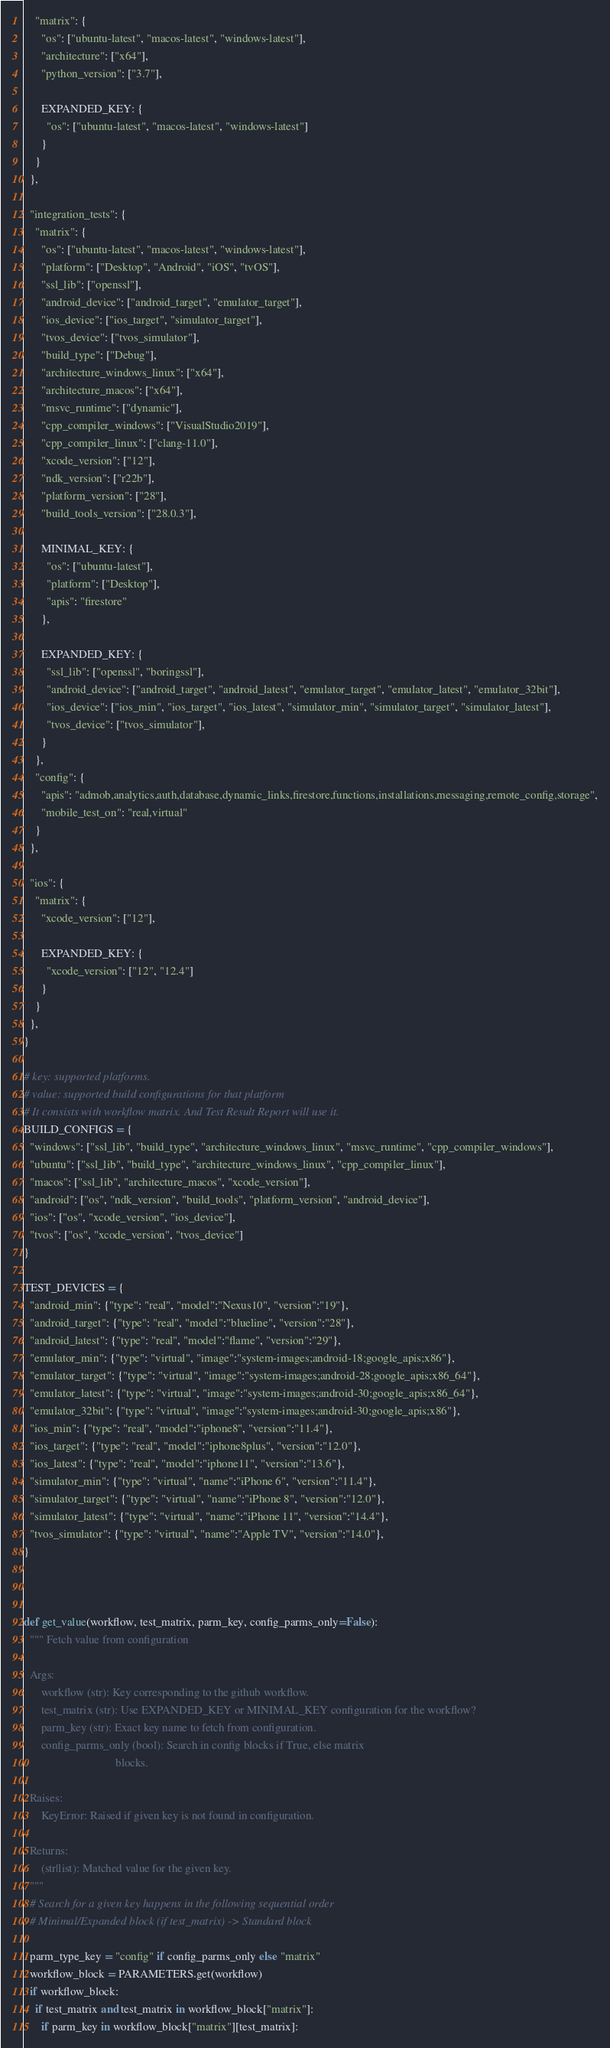Convert code to text. <code><loc_0><loc_0><loc_500><loc_500><_Python_>    "matrix": {
      "os": ["ubuntu-latest", "macos-latest", "windows-latest"],
      "architecture": ["x64"],
      "python_version": ["3.7"],

      EXPANDED_KEY: {
        "os": ["ubuntu-latest", "macos-latest", "windows-latest"]
      }
    }
  },

  "integration_tests": {
    "matrix": {
      "os": ["ubuntu-latest", "macos-latest", "windows-latest"],
      "platform": ["Desktop", "Android", "iOS", "tvOS"],
      "ssl_lib": ["openssl"],
      "android_device": ["android_target", "emulator_target"],
      "ios_device": ["ios_target", "simulator_target"],
      "tvos_device": ["tvos_simulator"],
      "build_type": ["Debug"],
      "architecture_windows_linux": ["x64"],
      "architecture_macos": ["x64"],
      "msvc_runtime": ["dynamic"],
      "cpp_compiler_windows": ["VisualStudio2019"],
      "cpp_compiler_linux": ["clang-11.0"],
      "xcode_version": ["12"],
      "ndk_version": ["r22b"],
      "platform_version": ["28"],
      "build_tools_version": ["28.0.3"],

      MINIMAL_KEY: {
        "os": ["ubuntu-latest"],
        "platform": ["Desktop"],
        "apis": "firestore"
      },

      EXPANDED_KEY: {
        "ssl_lib": ["openssl", "boringssl"],
        "android_device": ["android_target", "android_latest", "emulator_target", "emulator_latest", "emulator_32bit"],
        "ios_device": ["ios_min", "ios_target", "ios_latest", "simulator_min", "simulator_target", "simulator_latest"],
        "tvos_device": ["tvos_simulator"],
      }
    },
    "config": {
      "apis": "admob,analytics,auth,database,dynamic_links,firestore,functions,installations,messaging,remote_config,storage",
      "mobile_test_on": "real,virtual"
    }
  },

  "ios": {
    "matrix": {
      "xcode_version": ["12"],

      EXPANDED_KEY: {
        "xcode_version": ["12", "12.4"]
      }
    }
  },
}

# key: supported platforms.
# value: supported build configurations for that platform
# It consists with workflow matrix. And Test Result Report will use it.
BUILD_CONFIGS = {
  "windows": ["ssl_lib", "build_type", "architecture_windows_linux", "msvc_runtime", "cpp_compiler_windows"],
  "ubuntu": ["ssl_lib", "build_type", "architecture_windows_linux", "cpp_compiler_linux"],
  "macos": ["ssl_lib", "architecture_macos", "xcode_version"],
  "android": ["os", "ndk_version", "build_tools", "platform_version", "android_device"],
  "ios": ["os", "xcode_version", "ios_device"],
  "tvos": ["os", "xcode_version", "tvos_device"]
}

TEST_DEVICES = {
  "android_min": {"type": "real", "model":"Nexus10", "version":"19"},
  "android_target": {"type": "real", "model":"blueline", "version":"28"},
  "android_latest": {"type": "real", "model":"flame", "version":"29"},
  "emulator_min": {"type": "virtual", "image":"system-images;android-18;google_apis;x86"},
  "emulator_target": {"type": "virtual", "image":"system-images;android-28;google_apis;x86_64"},
  "emulator_latest": {"type": "virtual", "image":"system-images;android-30;google_apis;x86_64"},
  "emulator_32bit": {"type": "virtual", "image":"system-images;android-30;google_apis;x86"},
  "ios_min": {"type": "real", "model":"iphone8", "version":"11.4"},
  "ios_target": {"type": "real", "model":"iphone8plus", "version":"12.0"},
  "ios_latest": {"type": "real", "model":"iphone11", "version":"13.6"},
  "simulator_min": {"type": "virtual", "name":"iPhone 6", "version":"11.4"},
  "simulator_target": {"type": "virtual", "name":"iPhone 8", "version":"12.0"},
  "simulator_latest": {"type": "virtual", "name":"iPhone 11", "version":"14.4"},
  "tvos_simulator": {"type": "virtual", "name":"Apple TV", "version":"14.0"},
}
 


def get_value(workflow, test_matrix, parm_key, config_parms_only=False):
  """ Fetch value from configuration

  Args:
      workflow (str): Key corresponding to the github workflow.
      test_matrix (str): Use EXPANDED_KEY or MINIMAL_KEY configuration for the workflow?
      parm_key (str): Exact key name to fetch from configuration.
      config_parms_only (bool): Search in config blocks if True, else matrix
                                blocks.

  Raises:
      KeyError: Raised if given key is not found in configuration.

  Returns:
      (str|list): Matched value for the given key.
  """
  # Search for a given key happens in the following sequential order
  # Minimal/Expanded block (if test_matrix) -> Standard block

  parm_type_key = "config" if config_parms_only else "matrix"
  workflow_block = PARAMETERS.get(workflow)
  if workflow_block:
    if test_matrix and test_matrix in workflow_block["matrix"]:
      if parm_key in workflow_block["matrix"][test_matrix]:</code> 